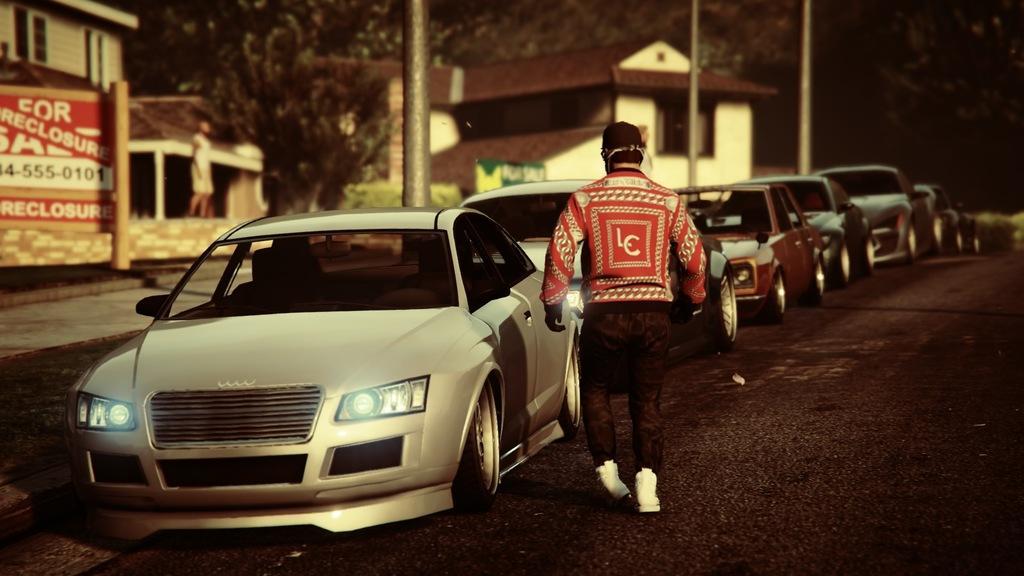How would you summarize this image in a sentence or two? This image is clicked outside. There are cars in the middle. There is a person in the middle. He is walking. There are trees at the top. There are some buildings in the middle. 